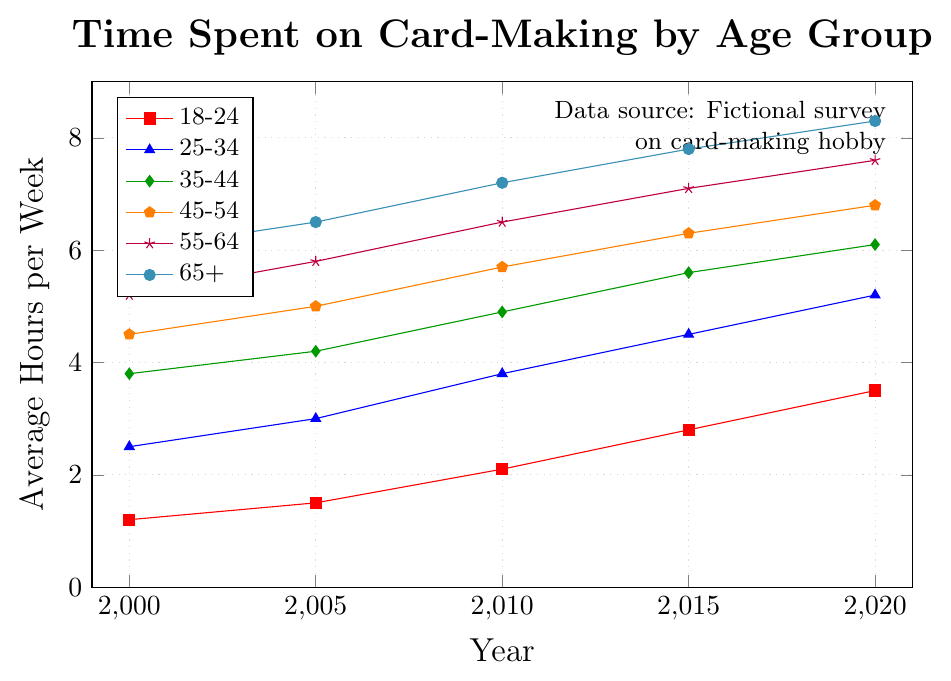Question 1: Which age group spent the most time on card-making in 2020? To find out which group spent the most time on card-making in 2020, look at the last data point (2020) of each age group. The group 65+ spent the most time, with 8.3 hours per week.
Answer: 65+ Question 2: How much more time did the 55-64 age group spend on card-making in 2005 compared to the 18-24 age group in that same year? Compare the time spent by the 55-64 (5.8 hours) and 18-24 (1.5 hours) age groups in 2005. The difference is 5.8 - 1.5 = 4.3 hours.
Answer: 4.3 hours Question 3: Which age group had the smallest increase in time spent on card-making from 2000 to 2020? Calculate the difference between the 2020 and 2000 data points for each age group. The smallest increase is for the 18-24 group, which increased from 1.2 to 3.5 hours (3.5 - 1.2 = 2.3 hours).
Answer: 18-24 Question 4: What is the average time spent on card-making across all age groups in 2010? Sum the 2010 data points for all age groups (2.1 + 3.8 + 4.9 + 5.7 + 6.5 + 7.2) and divide by the number of groups (6). The sum is 30.2; average is 30.2 / 6 = 5.03 hours.
Answer: 5.03 hours Question 5: Which age group spent less than 3 hours on card-making per week in 2015? Review the 2015 data points and identify those less than 3. The 18-24 age group spent 2.8 hours, which is less than 3 hours.
Answer: 18-24 Question 6: By how much did the time spent on card-making by the 35-44 age group in 2020 exceed that in 2000? Compare the 2020 (6.1 hours) data point with the 2000 (3.8 hours) data point for the 35-44 group. The difference is 6.1 - 3.8 = 2.3 hours.
Answer: 2.3 hours Question 7: Between 2000 and 2020, which two age groups showed identical trends in the increase of time spent on card-making? Identify groups showing the same increase by comparing their increments. Both 45-54 and 55-64 groups went from 4.5 to 6.8 hours, and 5.2 to 7.6 hours, respectively, showing a similar pattern over the years.
Answer: 45-54 and 55-64 Question 8: What is the overall trend in time spent on card-making across all age groups from 2000 to 2020? Observe the general direction of the lines in the plot from 2000 to 2020. The overall trend for all age groups shows an increase in time spent on card-making over the years.
Answer: Increasing Question 9: Which age group showed the greatest increase in time spent on card-making between any two consecutive years? Identify the largest increment between consecutive years for each group. The largest jump is for the 18-24 group from 2010 to 2015 (2.1 to 2.8, a 0.7-hour increase), but the biggest single jump belongs to 25-34 between 2005 to 2010 (3.0 to 3.8, a 0.8-hour increase).
Answer: 25-34 